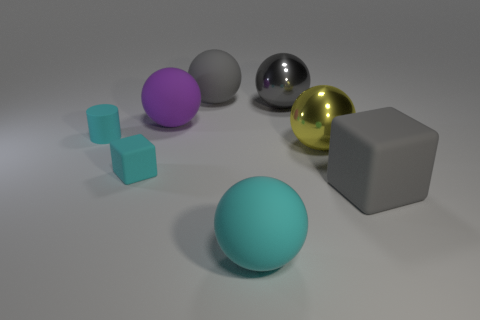Subtract all purple spheres. How many spheres are left? 4 Subtract all cyan balls. How many balls are left? 4 Subtract all blue spheres. Subtract all purple cubes. How many spheres are left? 5 Add 1 rubber spheres. How many objects exist? 9 Subtract all cubes. How many objects are left? 6 Subtract all small yellow rubber cubes. Subtract all matte things. How many objects are left? 2 Add 6 tiny rubber cylinders. How many tiny rubber cylinders are left? 7 Add 7 big cyan rubber blocks. How many big cyan rubber blocks exist? 7 Subtract 0 blue spheres. How many objects are left? 8 